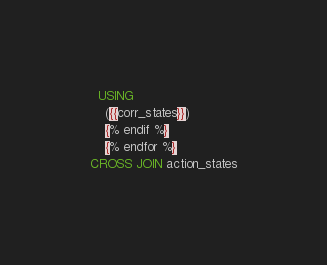<code> <loc_0><loc_0><loc_500><loc_500><_SQL_>  USING
    ({{corr_states}})
    {% endif %}
    {% endfor %}
CROSS JOIN action_states
</code> 